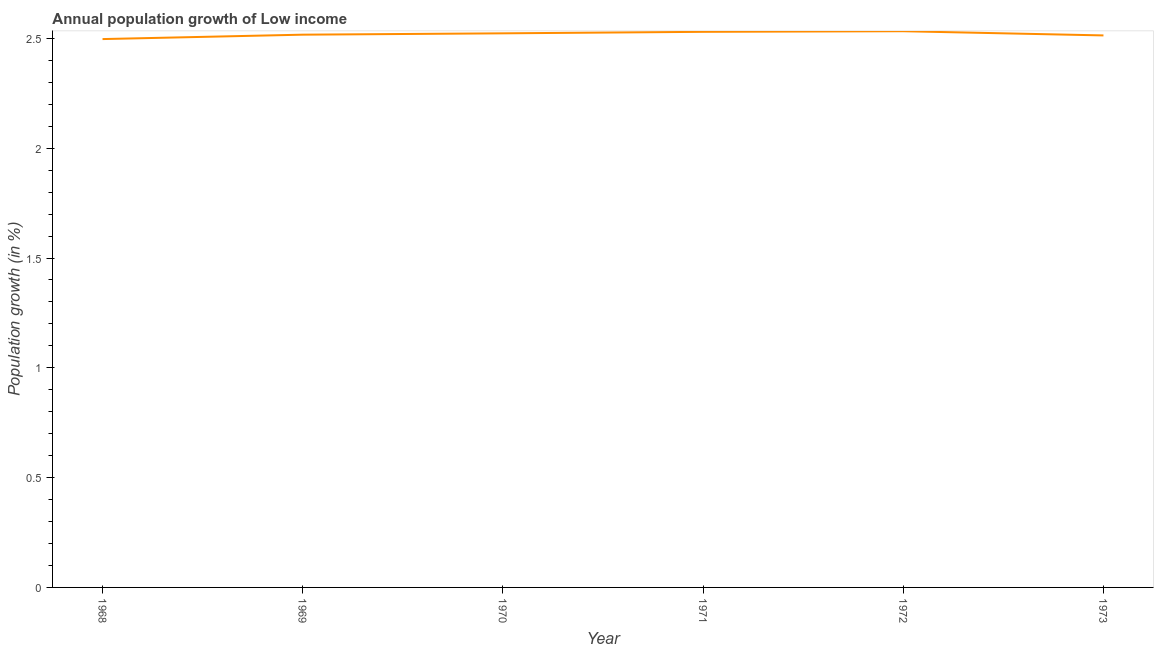What is the population growth in 1968?
Keep it short and to the point. 2.5. Across all years, what is the maximum population growth?
Your response must be concise. 2.53. Across all years, what is the minimum population growth?
Your response must be concise. 2.5. In which year was the population growth minimum?
Offer a very short reply. 1968. What is the sum of the population growth?
Your response must be concise. 15.11. What is the difference between the population growth in 1970 and 1973?
Your answer should be compact. 0.01. What is the average population growth per year?
Provide a short and direct response. 2.52. What is the median population growth?
Ensure brevity in your answer.  2.52. In how many years, is the population growth greater than 2.3 %?
Give a very brief answer. 6. Do a majority of the years between 1971 and 1970 (inclusive) have population growth greater than 1.3 %?
Your response must be concise. No. What is the ratio of the population growth in 1970 to that in 1971?
Make the answer very short. 1. Is the population growth in 1972 less than that in 1973?
Ensure brevity in your answer.  No. What is the difference between the highest and the second highest population growth?
Your answer should be very brief. 0. Is the sum of the population growth in 1972 and 1973 greater than the maximum population growth across all years?
Provide a succinct answer. Yes. What is the difference between the highest and the lowest population growth?
Offer a terse response. 0.04. In how many years, is the population growth greater than the average population growth taken over all years?
Offer a very short reply. 3. What is the difference between two consecutive major ticks on the Y-axis?
Your response must be concise. 0.5. Are the values on the major ticks of Y-axis written in scientific E-notation?
Provide a succinct answer. No. Does the graph contain any zero values?
Make the answer very short. No. What is the title of the graph?
Give a very brief answer. Annual population growth of Low income. What is the label or title of the X-axis?
Ensure brevity in your answer.  Year. What is the label or title of the Y-axis?
Keep it short and to the point. Population growth (in %). What is the Population growth (in %) in 1968?
Provide a succinct answer. 2.5. What is the Population growth (in %) of 1969?
Keep it short and to the point. 2.52. What is the Population growth (in %) in 1970?
Your answer should be very brief. 2.52. What is the Population growth (in %) in 1971?
Offer a very short reply. 2.53. What is the Population growth (in %) of 1972?
Keep it short and to the point. 2.53. What is the Population growth (in %) of 1973?
Offer a terse response. 2.51. What is the difference between the Population growth (in %) in 1968 and 1969?
Make the answer very short. -0.02. What is the difference between the Population growth (in %) in 1968 and 1970?
Keep it short and to the point. -0.03. What is the difference between the Population growth (in %) in 1968 and 1971?
Your response must be concise. -0.03. What is the difference between the Population growth (in %) in 1968 and 1972?
Offer a terse response. -0.04. What is the difference between the Population growth (in %) in 1968 and 1973?
Ensure brevity in your answer.  -0.02. What is the difference between the Population growth (in %) in 1969 and 1970?
Your answer should be very brief. -0.01. What is the difference between the Population growth (in %) in 1969 and 1971?
Make the answer very short. -0.01. What is the difference between the Population growth (in %) in 1969 and 1972?
Offer a very short reply. -0.02. What is the difference between the Population growth (in %) in 1969 and 1973?
Offer a very short reply. 0. What is the difference between the Population growth (in %) in 1970 and 1971?
Your answer should be compact. -0.01. What is the difference between the Population growth (in %) in 1970 and 1972?
Your response must be concise. -0.01. What is the difference between the Population growth (in %) in 1970 and 1973?
Keep it short and to the point. 0.01. What is the difference between the Population growth (in %) in 1971 and 1972?
Offer a very short reply. -0. What is the difference between the Population growth (in %) in 1971 and 1973?
Your answer should be compact. 0.02. What is the difference between the Population growth (in %) in 1972 and 1973?
Provide a succinct answer. 0.02. What is the ratio of the Population growth (in %) in 1968 to that in 1970?
Provide a short and direct response. 0.99. What is the ratio of the Population growth (in %) in 1968 to that in 1971?
Provide a succinct answer. 0.99. What is the ratio of the Population growth (in %) in 1968 to that in 1972?
Give a very brief answer. 0.99. What is the ratio of the Population growth (in %) in 1968 to that in 1973?
Offer a terse response. 0.99. What is the ratio of the Population growth (in %) in 1969 to that in 1972?
Offer a very short reply. 0.99. What is the ratio of the Population growth (in %) in 1971 to that in 1972?
Offer a terse response. 1. What is the ratio of the Population growth (in %) in 1972 to that in 1973?
Your response must be concise. 1.01. 